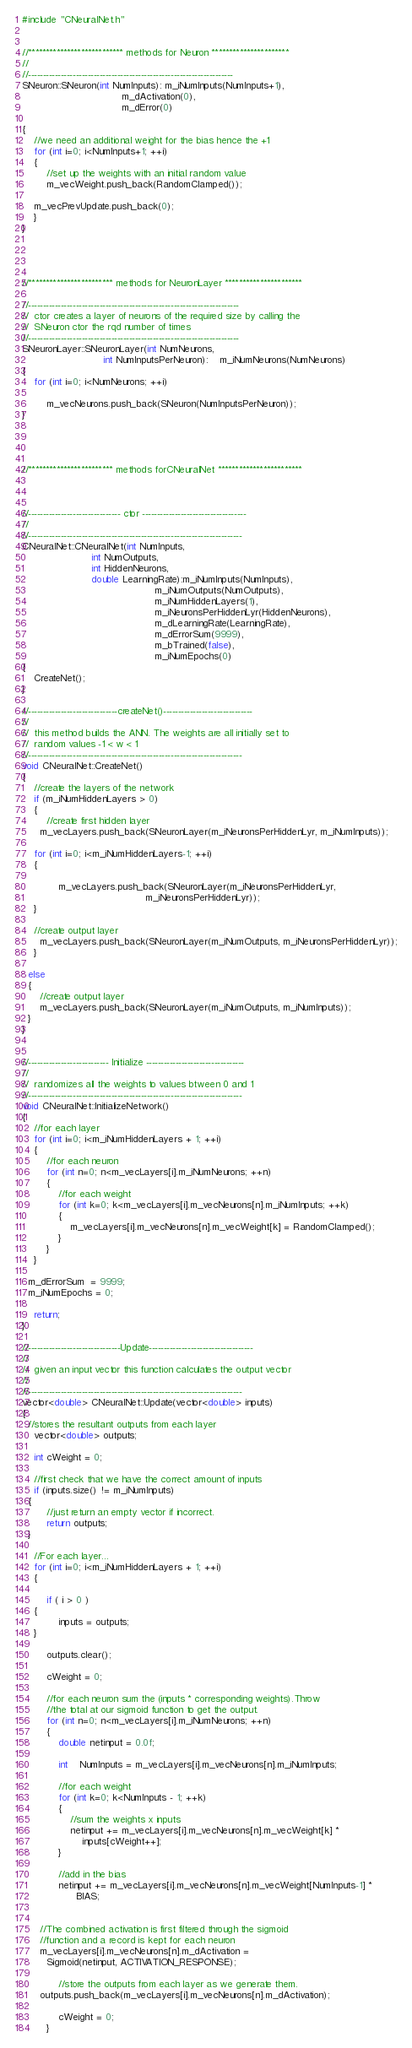<code> <loc_0><loc_0><loc_500><loc_500><_C++_>#include "CNeuralNet.h"


//*************************** methods for Neuron **********************
//
//---------------------------------------------------------------------
SNeuron::SNeuron(int NumInputs): m_iNumInputs(NumInputs+1),
                                 m_dActivation(0),
                                 m_dError(0)
											
{
	//we need an additional weight for the bias hence the +1
	for (int i=0; i<NumInputs+1; ++i)
	{
		//set up the weights with an initial random value
		m_vecWeight.push_back(RandomClamped());

    m_vecPrevUpdate.push_back(0);
	}
}




//************************ methods for NeuronLayer **********************

//-----------------------------------------------------------------------
//	ctor creates a layer of neurons of the required size by calling the 
//	SNeuron ctor the rqd number of times
//-----------------------------------------------------------------------
SNeuronLayer::SNeuronLayer(int NumNeurons, 
                           int NumInputsPerNeuron):	m_iNumNeurons(NumNeurons)
{
	for (int i=0; i<NumNeurons; ++i)

		m_vecNeurons.push_back(SNeuron(NumInputsPerNeuron));
}




//************************ methods forCNeuralNet ************************



//------------------------------- ctor -----------------------------------
//
//------------------------------------------------------------------------
CNeuralNet::CNeuralNet(int NumInputs,
                       int NumOutputs,
                       int HiddenNeurons,
                       double LearningRate):m_iNumInputs(NumInputs),
                                            m_iNumOutputs(NumOutputs),
                                            m_iNumHiddenLayers(1),
                                            m_iNeuronsPerHiddenLyr(HiddenNeurons),
                                            m_dLearningRate(LearningRate),
                                            m_dErrorSum(9999),
                                            m_bTrained(false),
                                            m_iNumEpochs(0)
{
	CreateNet();
}

//------------------------------createNet()------------------------------
//
//	this method builds the ANN. The weights are all initially set to 
//	random values -1 < w < 1
//------------------------------------------------------------------------
void CNeuralNet::CreateNet()
{
	//create the layers of the network
	if (m_iNumHiddenLayers > 0)
	{
		//create first hidden layer
	  m_vecLayers.push_back(SNeuronLayer(m_iNeuronsPerHiddenLyr, m_iNumInputs));
    
    for (int i=0; i<m_iNumHiddenLayers-1; ++i)
    {

			m_vecLayers.push_back(SNeuronLayer(m_iNeuronsPerHiddenLyr,
                                         m_iNeuronsPerHiddenLyr));
    }

    //create output layer
	  m_vecLayers.push_back(SNeuronLayer(m_iNumOutputs, m_iNeuronsPerHiddenLyr));
	}

  else
  {
	  //create output layer
	  m_vecLayers.push_back(SNeuronLayer(m_iNumOutputs, m_iNumInputs));
  }
}


//--------------------------- Initialize ---------------------------------
//
//  randomizes all the weights to values btween 0 and 1
//------------------------------------------------------------------------
void CNeuralNet::InitializeNetwork()
{
	//for each layer
	for (int i=0; i<m_iNumHiddenLayers + 1; ++i)
	{
		//for each neuron
		for (int n=0; n<m_vecLayers[i].m_iNumNeurons; ++n)
		{
			//for each weight
			for (int k=0; k<m_vecLayers[i].m_vecNeurons[n].m_iNumInputs; ++k)
			{
				m_vecLayers[i].m_vecNeurons[n].m_vecWeight[k] = RandomClamped();
			}
		}
	}

  m_dErrorSum  = 9999;
  m_iNumEpochs = 0;

	return;
}

//-------------------------------Update-----------------------------------
//
//	given an input vector this function calculates the output vector
//
//------------------------------------------------------------------------
vector<double> CNeuralNet::Update(vector<double> inputs)
{
  //stores the resultant outputs from each layer
	vector<double> outputs;
  
	int cWeight = 0;
	
	//first check that we have the correct amount of inputs
	if (inputs.size() != m_iNumInputs)
  {
		//just return an empty vector if incorrect.
		return outputs;
  }
	
	//For each layer...
	for (int i=0; i<m_iNumHiddenLayers + 1; ++i)
	{
		
		if ( i > 0 )
    {
			inputs = outputs;
    }

		outputs.clear();
		
		cWeight = 0;

		//for each neuron sum the (inputs * corresponding weights).Throw 
		//the total at our sigmoid function to get the output.
		for (int n=0; n<m_vecLayers[i].m_iNumNeurons; ++n)
		{
			double netinput = 0.0f;

			int	NumInputs = m_vecLayers[i].m_vecNeurons[n].m_iNumInputs;
			
			//for each weight
			for (int k=0; k<NumInputs - 1; ++k)
			{
				//sum the weights x inputs
				netinput += m_vecLayers[i].m_vecNeurons[n].m_vecWeight[k] * 
                    inputs[cWeight++];
			}

			//add in the bias
			netinput += m_vecLayers[i].m_vecNeurons[n].m_vecWeight[NumInputs-1] * 
                  BIAS;

			 
      //The combined activation is first filtered through the sigmoid 
      //function and a record is kept for each neuron 
      m_vecLayers[i].m_vecNeurons[n].m_dActivation = 
        Sigmoid(netinput, ACTIVATION_RESPONSE);

			//store the outputs from each layer as we generate them.
      outputs.push_back(m_vecLayers[i].m_vecNeurons[n].m_dActivation);

			cWeight = 0;
		}</code> 